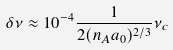Convert formula to latex. <formula><loc_0><loc_0><loc_500><loc_500>\delta \nu \approx 1 0 ^ { - 4 } \frac { 1 } { 2 ( n _ { A } a _ { 0 } ) ^ { 2 / 3 } } \nu _ { c }</formula> 